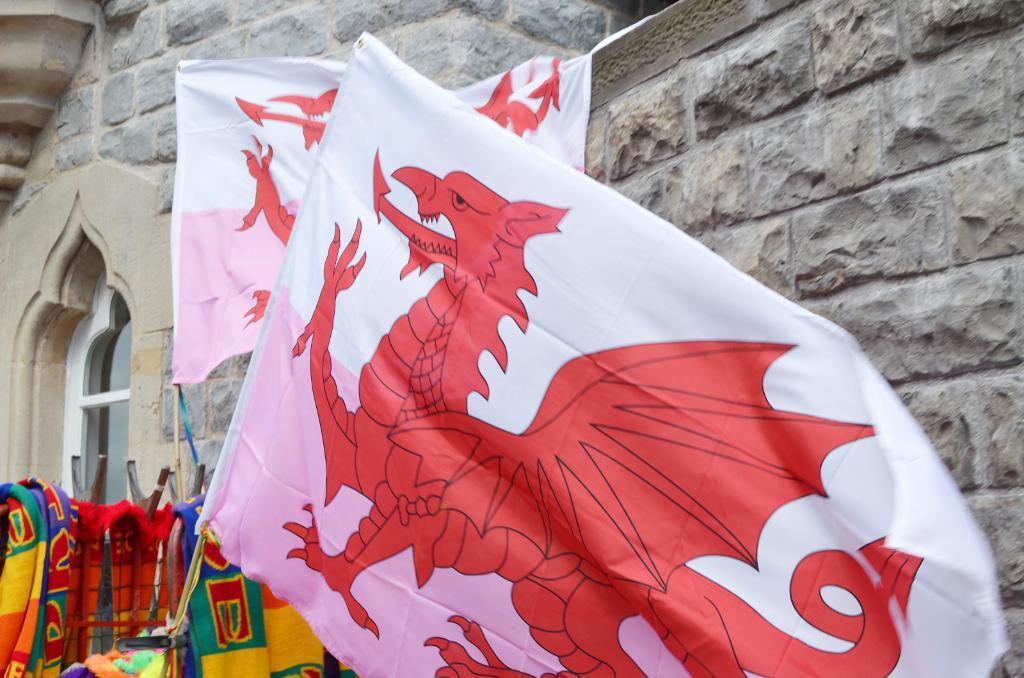Describe this image in one or two sentences. These are the flags, which are hanging to the wooden sticks. I can see the colorful clothes. This looks like a building. I think this is a glass door. I can see an arch. 